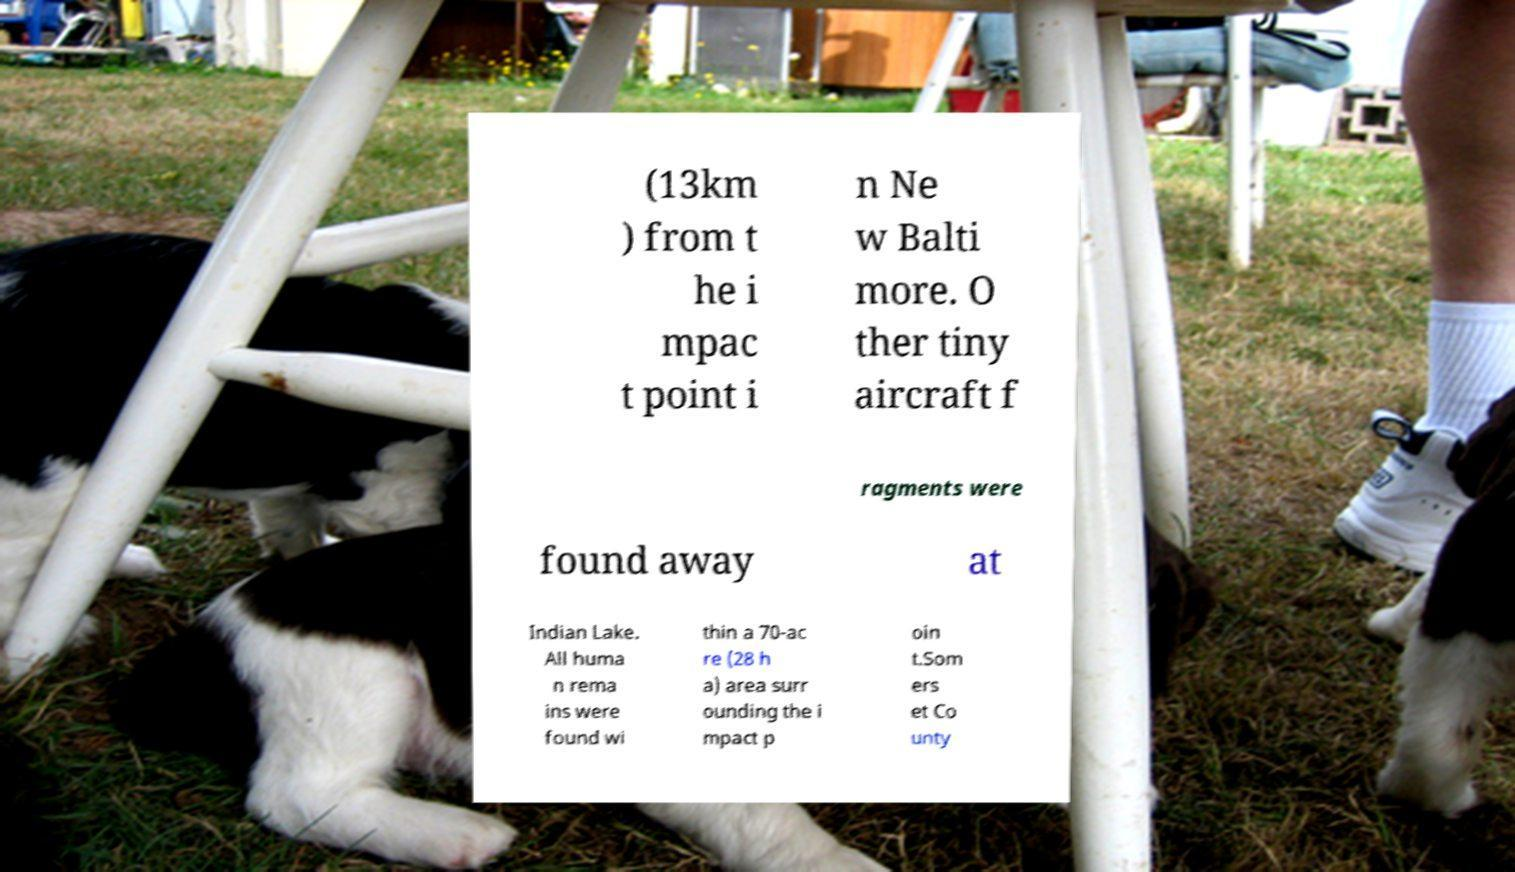I need the written content from this picture converted into text. Can you do that? (13km ) from t he i mpac t point i n Ne w Balti more. O ther tiny aircraft f ragments were found away at Indian Lake. All huma n rema ins were found wi thin a 70-ac re (28 h a) area surr ounding the i mpact p oin t.Som ers et Co unty 